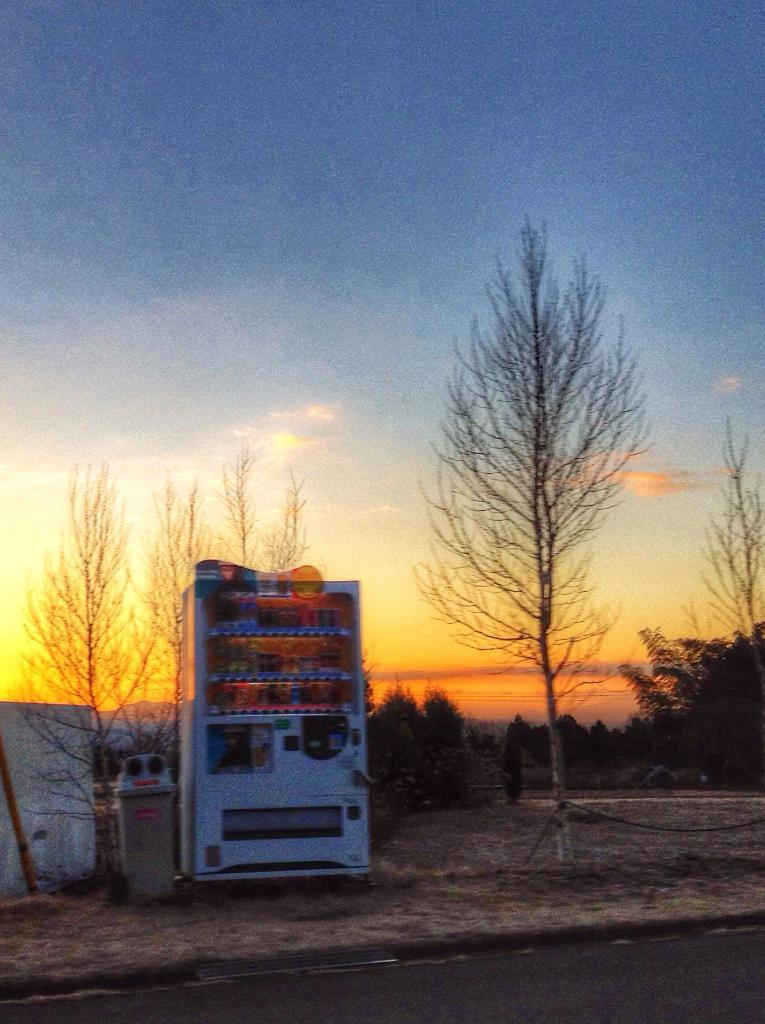What can be seen in the image? There are objects and trees in the image. Can you describe the wall in the image? Yes, there is a wall in the image. What is visible in the background of the image? The sky is visible in the background of the image. What type of alley can be seen between the trees in the image? There is no alley present in the image; it features objects, trees, a wall, and the sky. How many branches are visible on the trees in the image? The number of branches on the trees cannot be determined from the image, as it only provides a general view of the trees. 